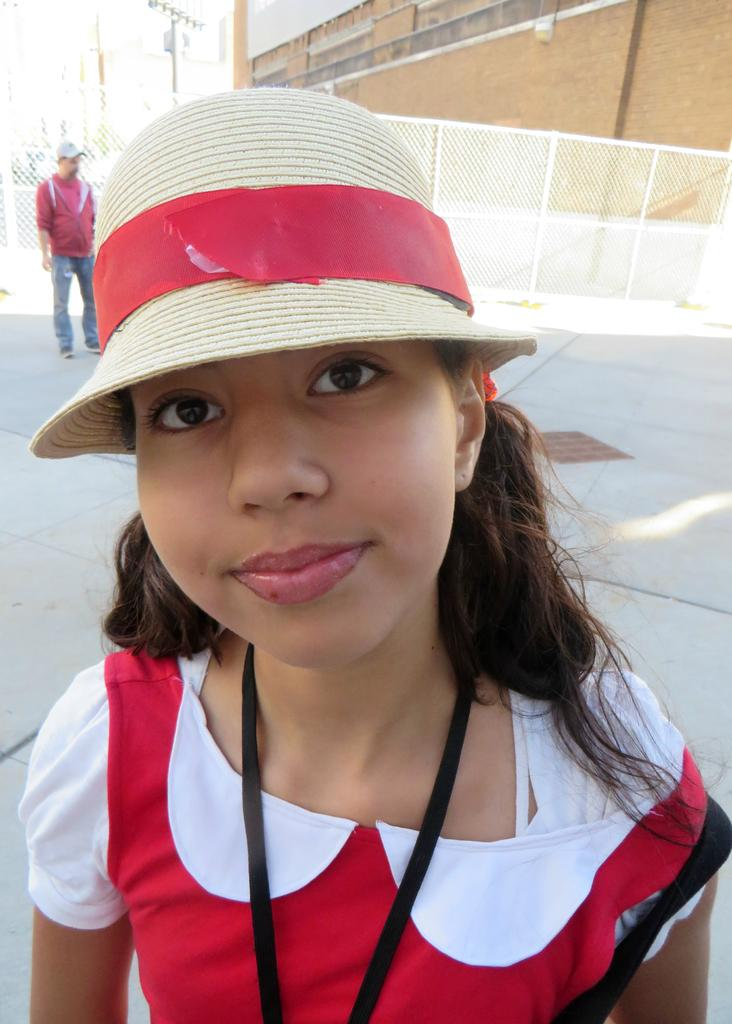What is one characteristic of the person in the image? There is a person with a hat in the image. Can you describe another person in the image? There is another person standing in the image. What type of barrier is present in the image? There is a wire fence in the image. What can be seen in the distance in the image? There is a building in the background of the image. What type of pump is being used by the person in the image? There is no pump present in the image. What type of shoe is the person wearing in the image? The image does not show the person's shoes, so it cannot be determined what type of shoe they are wearing. 